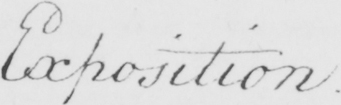What is written in this line of handwriting? Exposition 